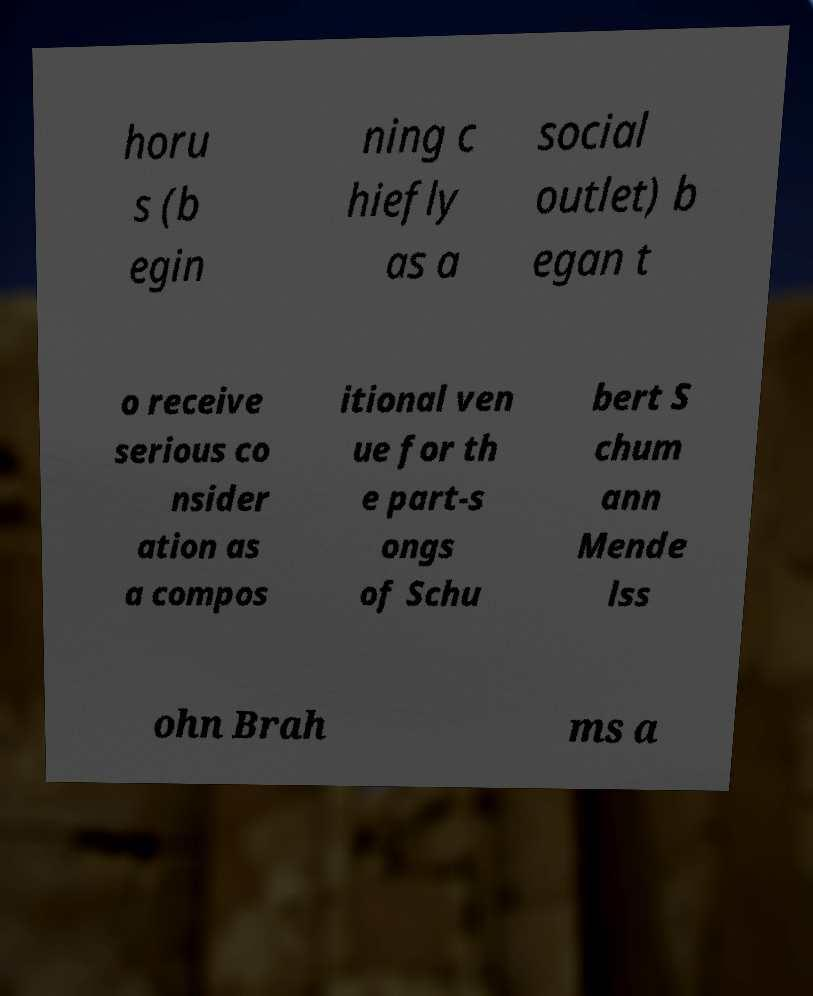Please identify and transcribe the text found in this image. horu s (b egin ning c hiefly as a social outlet) b egan t o receive serious co nsider ation as a compos itional ven ue for th e part-s ongs of Schu bert S chum ann Mende lss ohn Brah ms a 